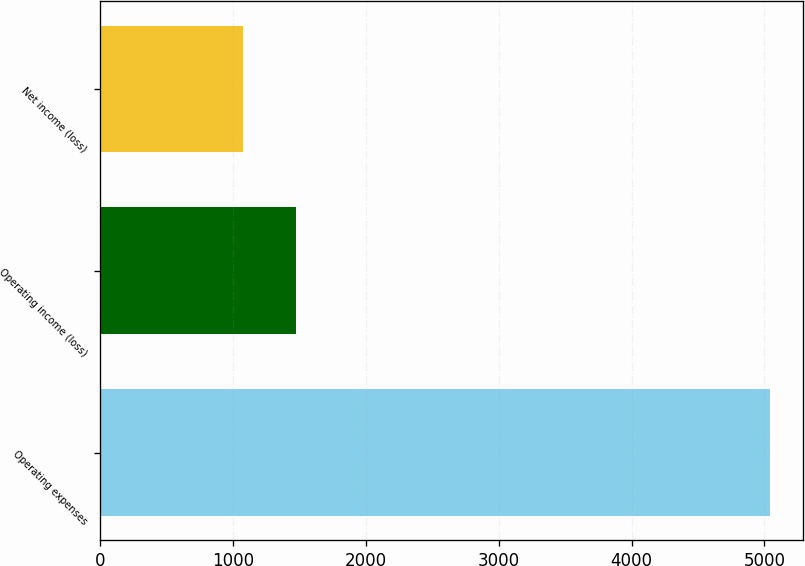<chart> <loc_0><loc_0><loc_500><loc_500><bar_chart><fcel>Operating expenses<fcel>Operating income (loss)<fcel>Net income (loss)<nl><fcel>5039<fcel>1472.3<fcel>1076<nl></chart> 